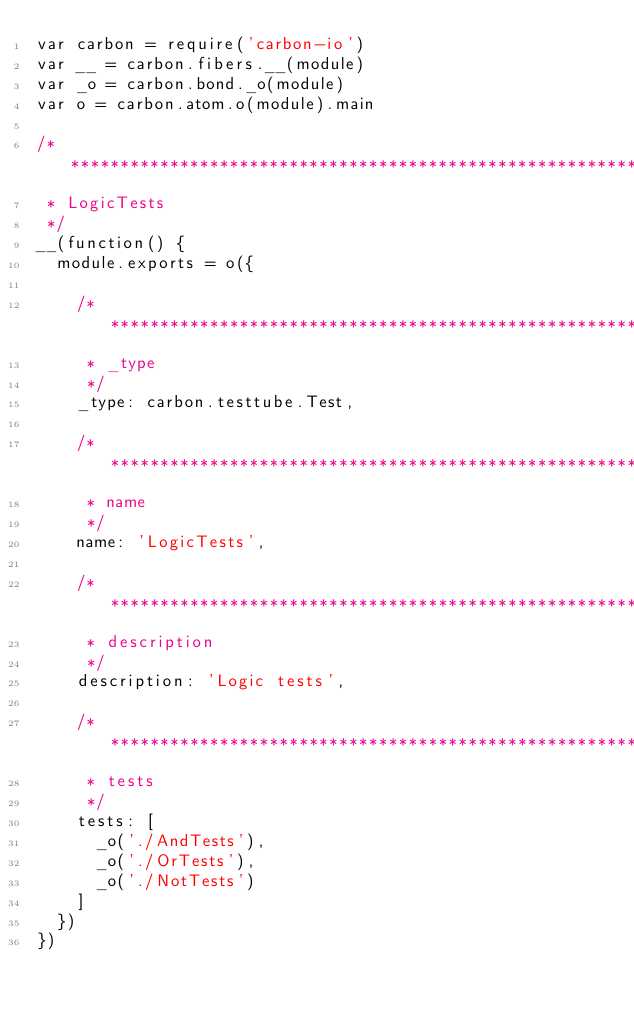Convert code to text. <code><loc_0><loc_0><loc_500><loc_500><_JavaScript_>var carbon = require('carbon-io')
var __ = carbon.fibers.__(module)
var _o = carbon.bond._o(module)
var o = carbon.atom.o(module).main

/**************************************************************************
 * LogicTests
 */
__(function() {
  module.exports = o({

    /**********************************************************************
     * _type
     */
    _type: carbon.testtube.Test,
    
    /**********************************************************************
     * name
     */
    name: 'LogicTests',

    /**********************************************************************
     * description
     */
    description: 'Logic tests',

    /**********************************************************************
     * tests
     */
    tests: [
      _o('./AndTests'),
      _o('./OrTests'),
      _o('./NotTests')
    ]
  })
})
</code> 